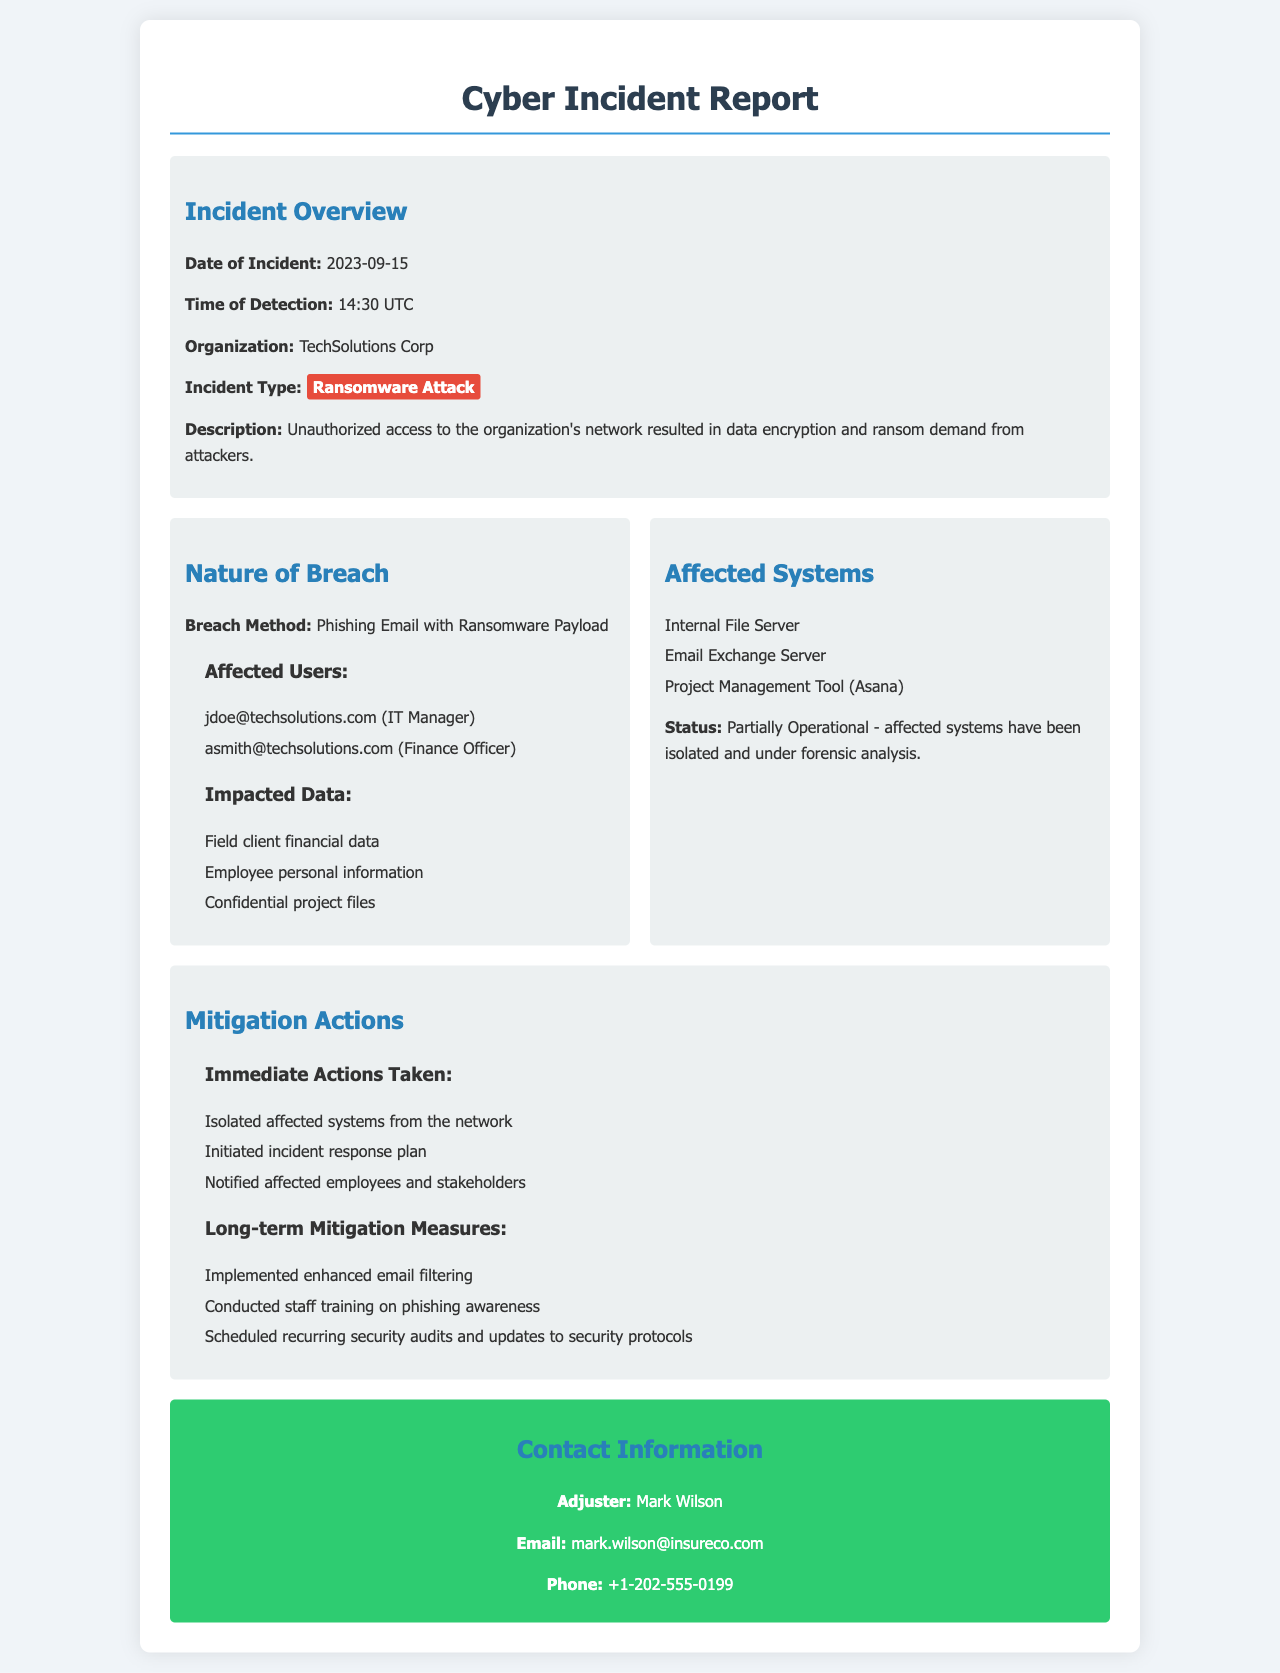what is the date of the incident? The date of the incident is specifically stated in the overview section of the document.
Answer: 2023-09-15 who is the organization involved? The organization involved is mentioned prominently in the incident overview.
Answer: TechSolutions Corp what is the incident type? The incident type is highlighted in the overview section of the document, indicating the nature of the issue.
Answer: Ransomware Attack how many affected users are listed? The document lists individuals under the affected users section, giving a count of those impacted.
Answer: 2 what method was used for the breach? This information is found under the "Nature of Breach" section, detailing how the breach occurred.
Answer: Phishing Email with Ransomware Payload which systems are affected? The affected systems are enumerated in a list format under the relevant section in the document.
Answer: Internal File Server, Email Exchange Server, Project Management Tool (Asana) what immediate action was taken first? The first action listed under immediate actions taken provides insight into the response to the incident.
Answer: Isolated affected systems from the network what long-term measure was implemented? This information is available under the "Long-term Mitigation Measures" section, detailing the strategic response post-incident.
Answer: Implemented enhanced email filtering who is the contact adjuster? The document provides the name of the adjuster in the contact information section, relevant for follow-up.
Answer: Mark Wilson 